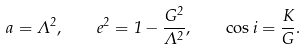<formula> <loc_0><loc_0><loc_500><loc_500>a = \Lambda ^ { 2 } , \quad e ^ { 2 } = 1 - \frac { G ^ { 2 } } { \Lambda ^ { 2 } } , \quad \cos i = \frac { K } { G } .</formula> 